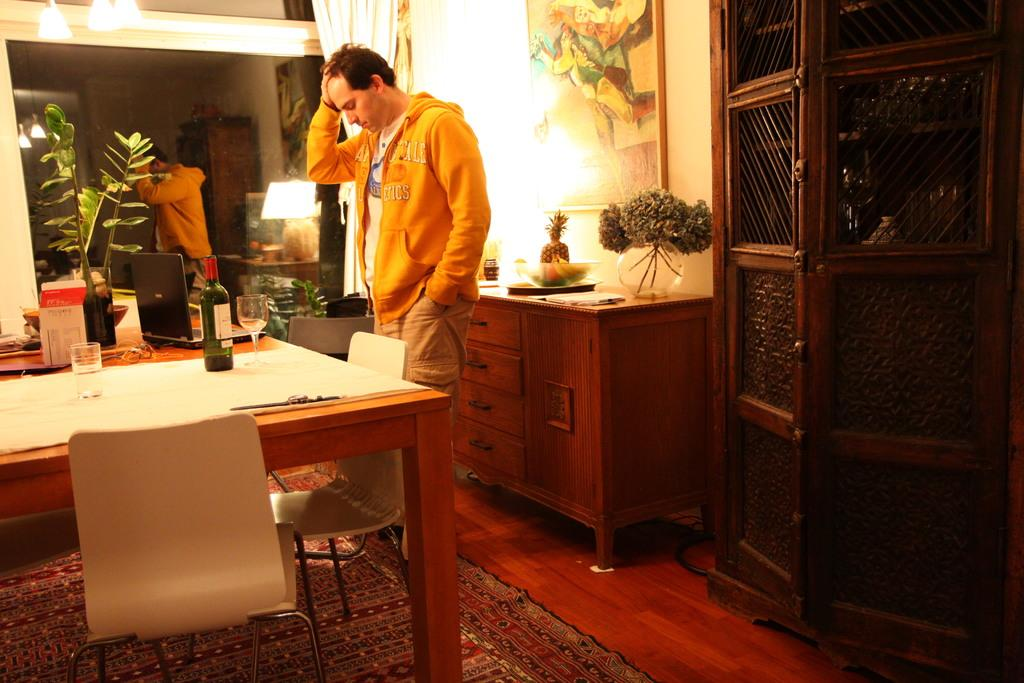Who is present in the image? There is a man in the image. What is in front of the man? There is a table in front of the man. What electronic device is on the table? There is a laptop on the table. What else is on the table besides the laptop? There is a beer bottle and a glass on the table. How many apples are on the table in the image? There are no apples present in the image. What type of gate is visible in the background of the image? There is no gate visible in the image. 